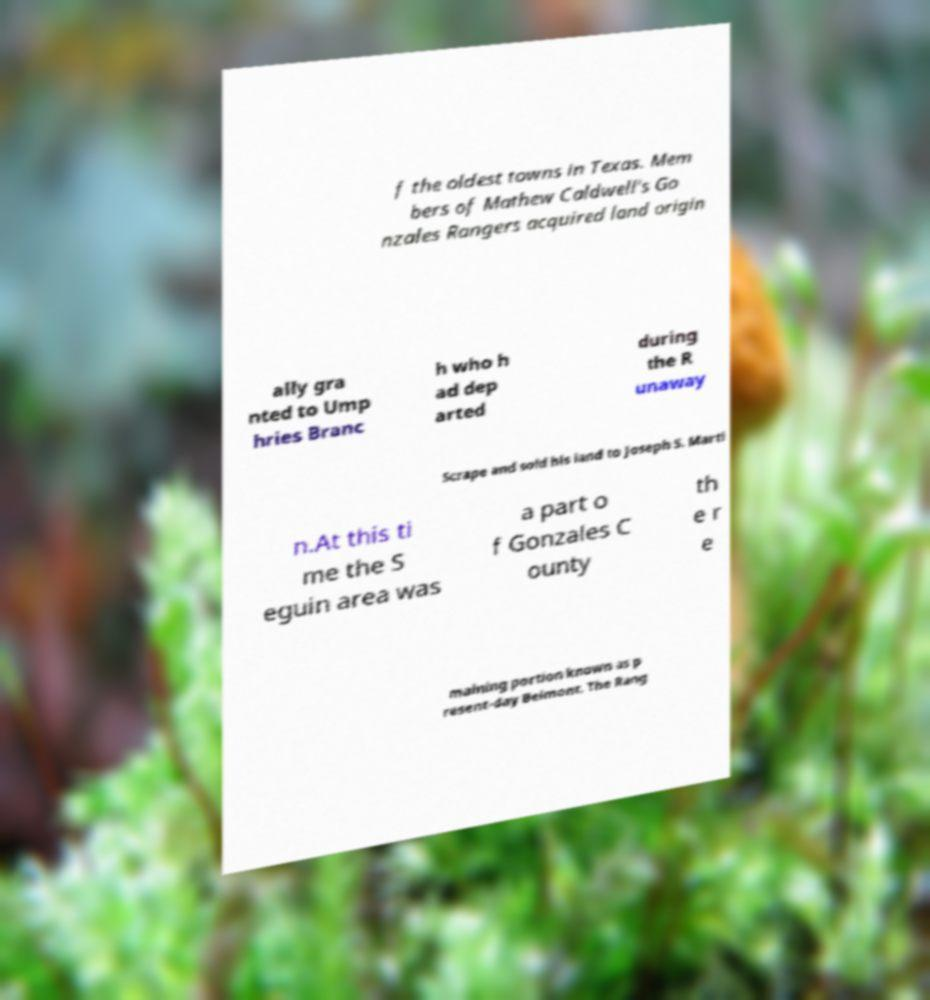For documentation purposes, I need the text within this image transcribed. Could you provide that? f the oldest towns in Texas. Mem bers of Mathew Caldwell's Go nzales Rangers acquired land origin ally gra nted to Ump hries Branc h who h ad dep arted during the R unaway Scrape and sold his land to Joseph S. Marti n.At this ti me the S eguin area was a part o f Gonzales C ounty th e r e maining portion known as p resent-day Belmont. The Rang 